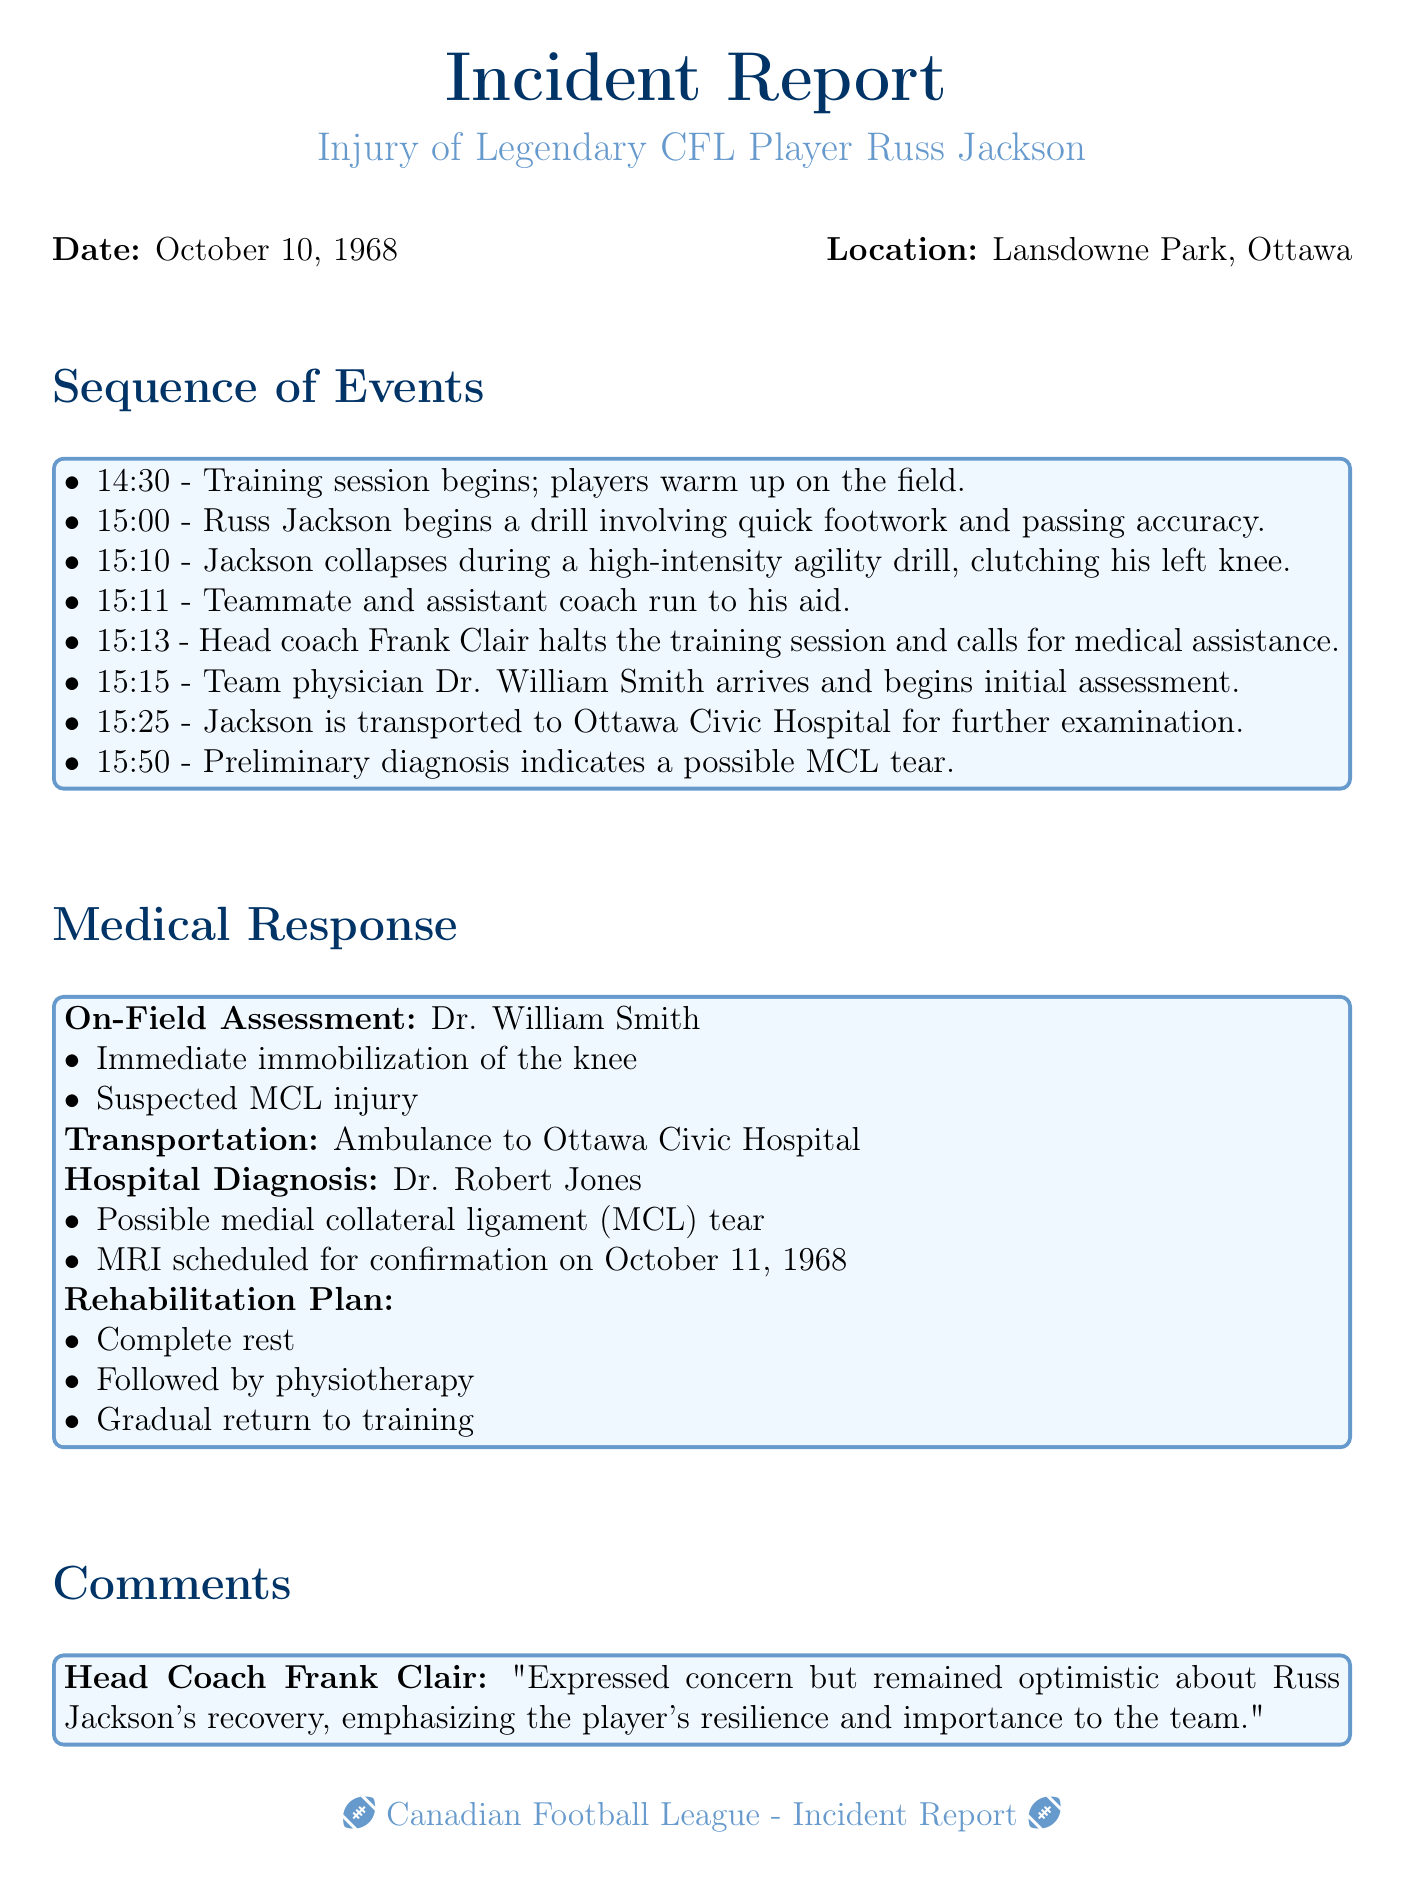What is the date of the incident? The date of the incident is mentioned at the beginning of the report, specifically listed as October 10, 1968.
Answer: October 10, 1968 What time did Russ Jackson collapse? The report indicates that Jackson collapsed during the agility drill at 15:10.
Answer: 15:10 Who was the team physician on the scene? The team physician who arrived to assist Jackson is identified as Dr. William Smith.
Answer: Dr. William Smith What injury was suspected after the preliminary diagnosis? The document states that the preliminary diagnosis indicated a possible MCL tear.
Answer: MCL tear What was the rehabilitation plan for Russ Jackson? The rehabilitation plan involves complete rest, followed by physiotherapy and a gradual return to training.
Answer: Complete rest, physiotherapy, gradual return to training What time was the training session halted? According to the sequence of events, the training session was halted at 15:13 after Jackson collapsed.
Answer: 15:13 What was the location of the incident? The report specifies that the incident took place at Lansdowne Park, Ottawa.
Answer: Lansdowne Park, Ottawa Who expressed concern but remained optimistic about Jackson's recovery? The head coach Frank Clair is quoted as expressing concern but remaining optimistic.
Answer: Frank Clair 